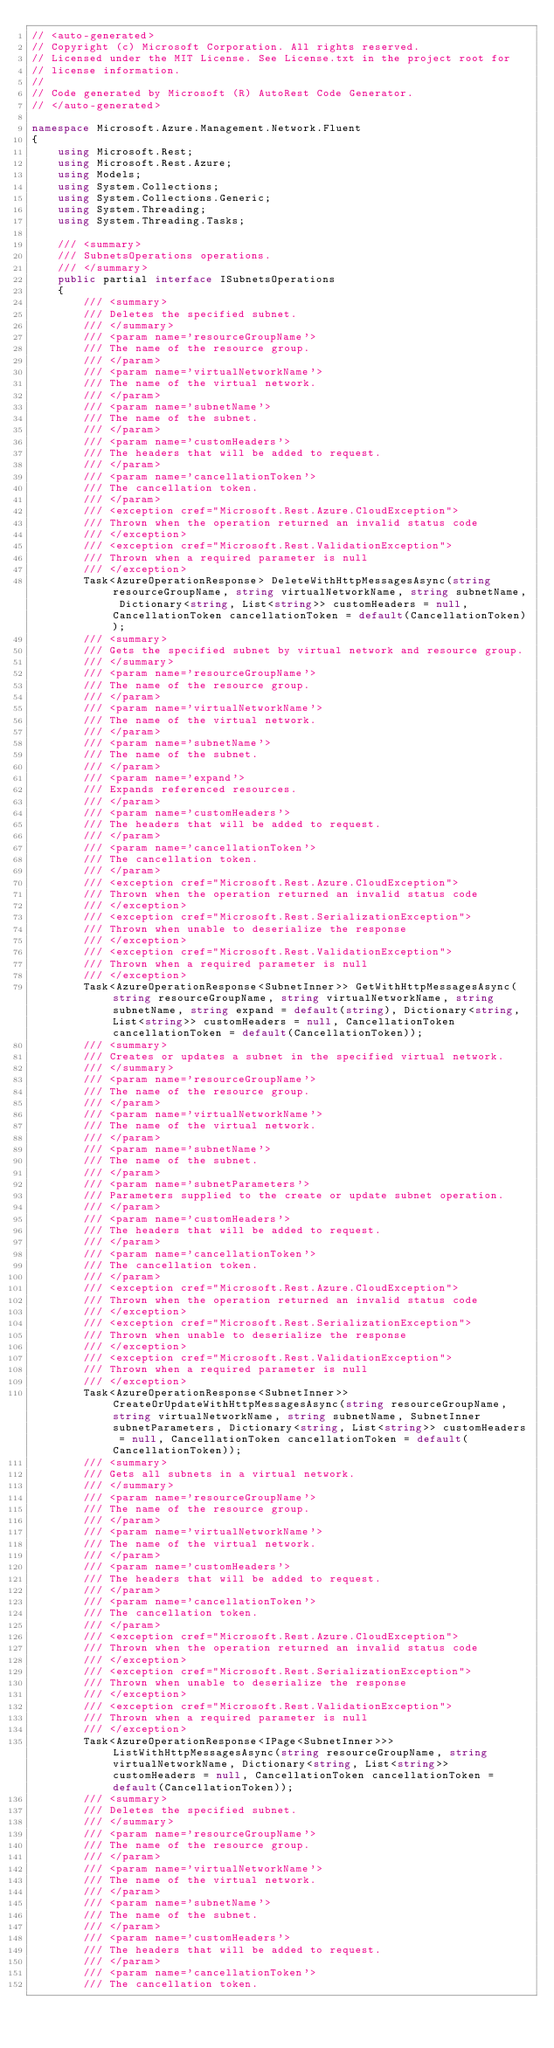Convert code to text. <code><loc_0><loc_0><loc_500><loc_500><_C#_>// <auto-generated>
// Copyright (c) Microsoft Corporation. All rights reserved.
// Licensed under the MIT License. See License.txt in the project root for
// license information.
//
// Code generated by Microsoft (R) AutoRest Code Generator.
// </auto-generated>

namespace Microsoft.Azure.Management.Network.Fluent
{
    using Microsoft.Rest;
    using Microsoft.Rest.Azure;
    using Models;
    using System.Collections;
    using System.Collections.Generic;
    using System.Threading;
    using System.Threading.Tasks;

    /// <summary>
    /// SubnetsOperations operations.
    /// </summary>
    public partial interface ISubnetsOperations
    {
        /// <summary>
        /// Deletes the specified subnet.
        /// </summary>
        /// <param name='resourceGroupName'>
        /// The name of the resource group.
        /// </param>
        /// <param name='virtualNetworkName'>
        /// The name of the virtual network.
        /// </param>
        /// <param name='subnetName'>
        /// The name of the subnet.
        /// </param>
        /// <param name='customHeaders'>
        /// The headers that will be added to request.
        /// </param>
        /// <param name='cancellationToken'>
        /// The cancellation token.
        /// </param>
        /// <exception cref="Microsoft.Rest.Azure.CloudException">
        /// Thrown when the operation returned an invalid status code
        /// </exception>
        /// <exception cref="Microsoft.Rest.ValidationException">
        /// Thrown when a required parameter is null
        /// </exception>
        Task<AzureOperationResponse> DeleteWithHttpMessagesAsync(string resourceGroupName, string virtualNetworkName, string subnetName, Dictionary<string, List<string>> customHeaders = null, CancellationToken cancellationToken = default(CancellationToken));
        /// <summary>
        /// Gets the specified subnet by virtual network and resource group.
        /// </summary>
        /// <param name='resourceGroupName'>
        /// The name of the resource group.
        /// </param>
        /// <param name='virtualNetworkName'>
        /// The name of the virtual network.
        /// </param>
        /// <param name='subnetName'>
        /// The name of the subnet.
        /// </param>
        /// <param name='expand'>
        /// Expands referenced resources.
        /// </param>
        /// <param name='customHeaders'>
        /// The headers that will be added to request.
        /// </param>
        /// <param name='cancellationToken'>
        /// The cancellation token.
        /// </param>
        /// <exception cref="Microsoft.Rest.Azure.CloudException">
        /// Thrown when the operation returned an invalid status code
        /// </exception>
        /// <exception cref="Microsoft.Rest.SerializationException">
        /// Thrown when unable to deserialize the response
        /// </exception>
        /// <exception cref="Microsoft.Rest.ValidationException">
        /// Thrown when a required parameter is null
        /// </exception>
        Task<AzureOperationResponse<SubnetInner>> GetWithHttpMessagesAsync(string resourceGroupName, string virtualNetworkName, string subnetName, string expand = default(string), Dictionary<string, List<string>> customHeaders = null, CancellationToken cancellationToken = default(CancellationToken));
        /// <summary>
        /// Creates or updates a subnet in the specified virtual network.
        /// </summary>
        /// <param name='resourceGroupName'>
        /// The name of the resource group.
        /// </param>
        /// <param name='virtualNetworkName'>
        /// The name of the virtual network.
        /// </param>
        /// <param name='subnetName'>
        /// The name of the subnet.
        /// </param>
        /// <param name='subnetParameters'>
        /// Parameters supplied to the create or update subnet operation.
        /// </param>
        /// <param name='customHeaders'>
        /// The headers that will be added to request.
        /// </param>
        /// <param name='cancellationToken'>
        /// The cancellation token.
        /// </param>
        /// <exception cref="Microsoft.Rest.Azure.CloudException">
        /// Thrown when the operation returned an invalid status code
        /// </exception>
        /// <exception cref="Microsoft.Rest.SerializationException">
        /// Thrown when unable to deserialize the response
        /// </exception>
        /// <exception cref="Microsoft.Rest.ValidationException">
        /// Thrown when a required parameter is null
        /// </exception>
        Task<AzureOperationResponse<SubnetInner>> CreateOrUpdateWithHttpMessagesAsync(string resourceGroupName, string virtualNetworkName, string subnetName, SubnetInner subnetParameters, Dictionary<string, List<string>> customHeaders = null, CancellationToken cancellationToken = default(CancellationToken));
        /// <summary>
        /// Gets all subnets in a virtual network.
        /// </summary>
        /// <param name='resourceGroupName'>
        /// The name of the resource group.
        /// </param>
        /// <param name='virtualNetworkName'>
        /// The name of the virtual network.
        /// </param>
        /// <param name='customHeaders'>
        /// The headers that will be added to request.
        /// </param>
        /// <param name='cancellationToken'>
        /// The cancellation token.
        /// </param>
        /// <exception cref="Microsoft.Rest.Azure.CloudException">
        /// Thrown when the operation returned an invalid status code
        /// </exception>
        /// <exception cref="Microsoft.Rest.SerializationException">
        /// Thrown when unable to deserialize the response
        /// </exception>
        /// <exception cref="Microsoft.Rest.ValidationException">
        /// Thrown when a required parameter is null
        /// </exception>
        Task<AzureOperationResponse<IPage<SubnetInner>>> ListWithHttpMessagesAsync(string resourceGroupName, string virtualNetworkName, Dictionary<string, List<string>> customHeaders = null, CancellationToken cancellationToken = default(CancellationToken));
        /// <summary>
        /// Deletes the specified subnet.
        /// </summary>
        /// <param name='resourceGroupName'>
        /// The name of the resource group.
        /// </param>
        /// <param name='virtualNetworkName'>
        /// The name of the virtual network.
        /// </param>
        /// <param name='subnetName'>
        /// The name of the subnet.
        /// </param>
        /// <param name='customHeaders'>
        /// The headers that will be added to request.
        /// </param>
        /// <param name='cancellationToken'>
        /// The cancellation token.</code> 